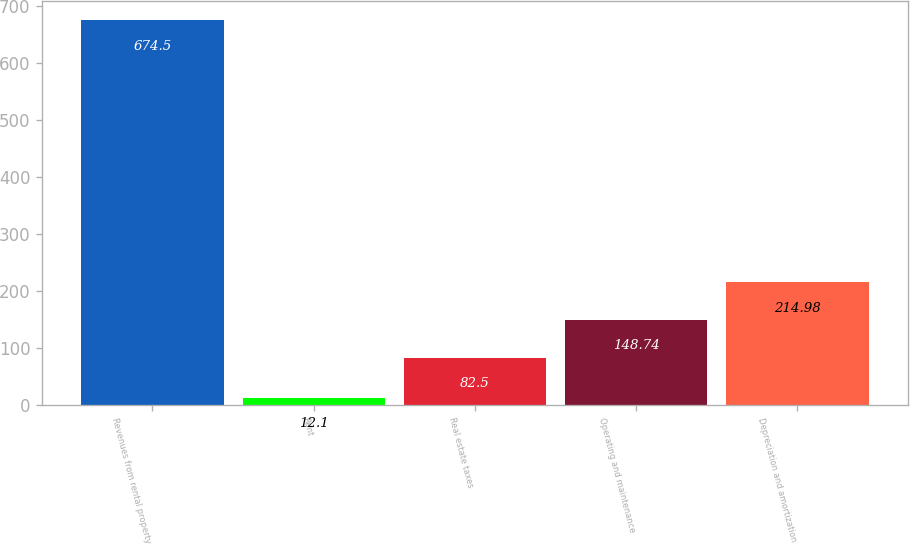<chart> <loc_0><loc_0><loc_500><loc_500><bar_chart><fcel>Revenues from rental property<fcel>Rent<fcel>Real estate taxes<fcel>Operating and maintenance<fcel>Depreciation and amortization<nl><fcel>674.5<fcel>12.1<fcel>82.5<fcel>148.74<fcel>214.98<nl></chart> 